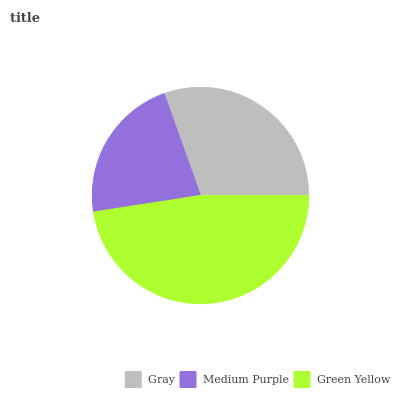Is Medium Purple the minimum?
Answer yes or no. Yes. Is Green Yellow the maximum?
Answer yes or no. Yes. Is Green Yellow the minimum?
Answer yes or no. No. Is Medium Purple the maximum?
Answer yes or no. No. Is Green Yellow greater than Medium Purple?
Answer yes or no. Yes. Is Medium Purple less than Green Yellow?
Answer yes or no. Yes. Is Medium Purple greater than Green Yellow?
Answer yes or no. No. Is Green Yellow less than Medium Purple?
Answer yes or no. No. Is Gray the high median?
Answer yes or no. Yes. Is Gray the low median?
Answer yes or no. Yes. Is Medium Purple the high median?
Answer yes or no. No. Is Medium Purple the low median?
Answer yes or no. No. 